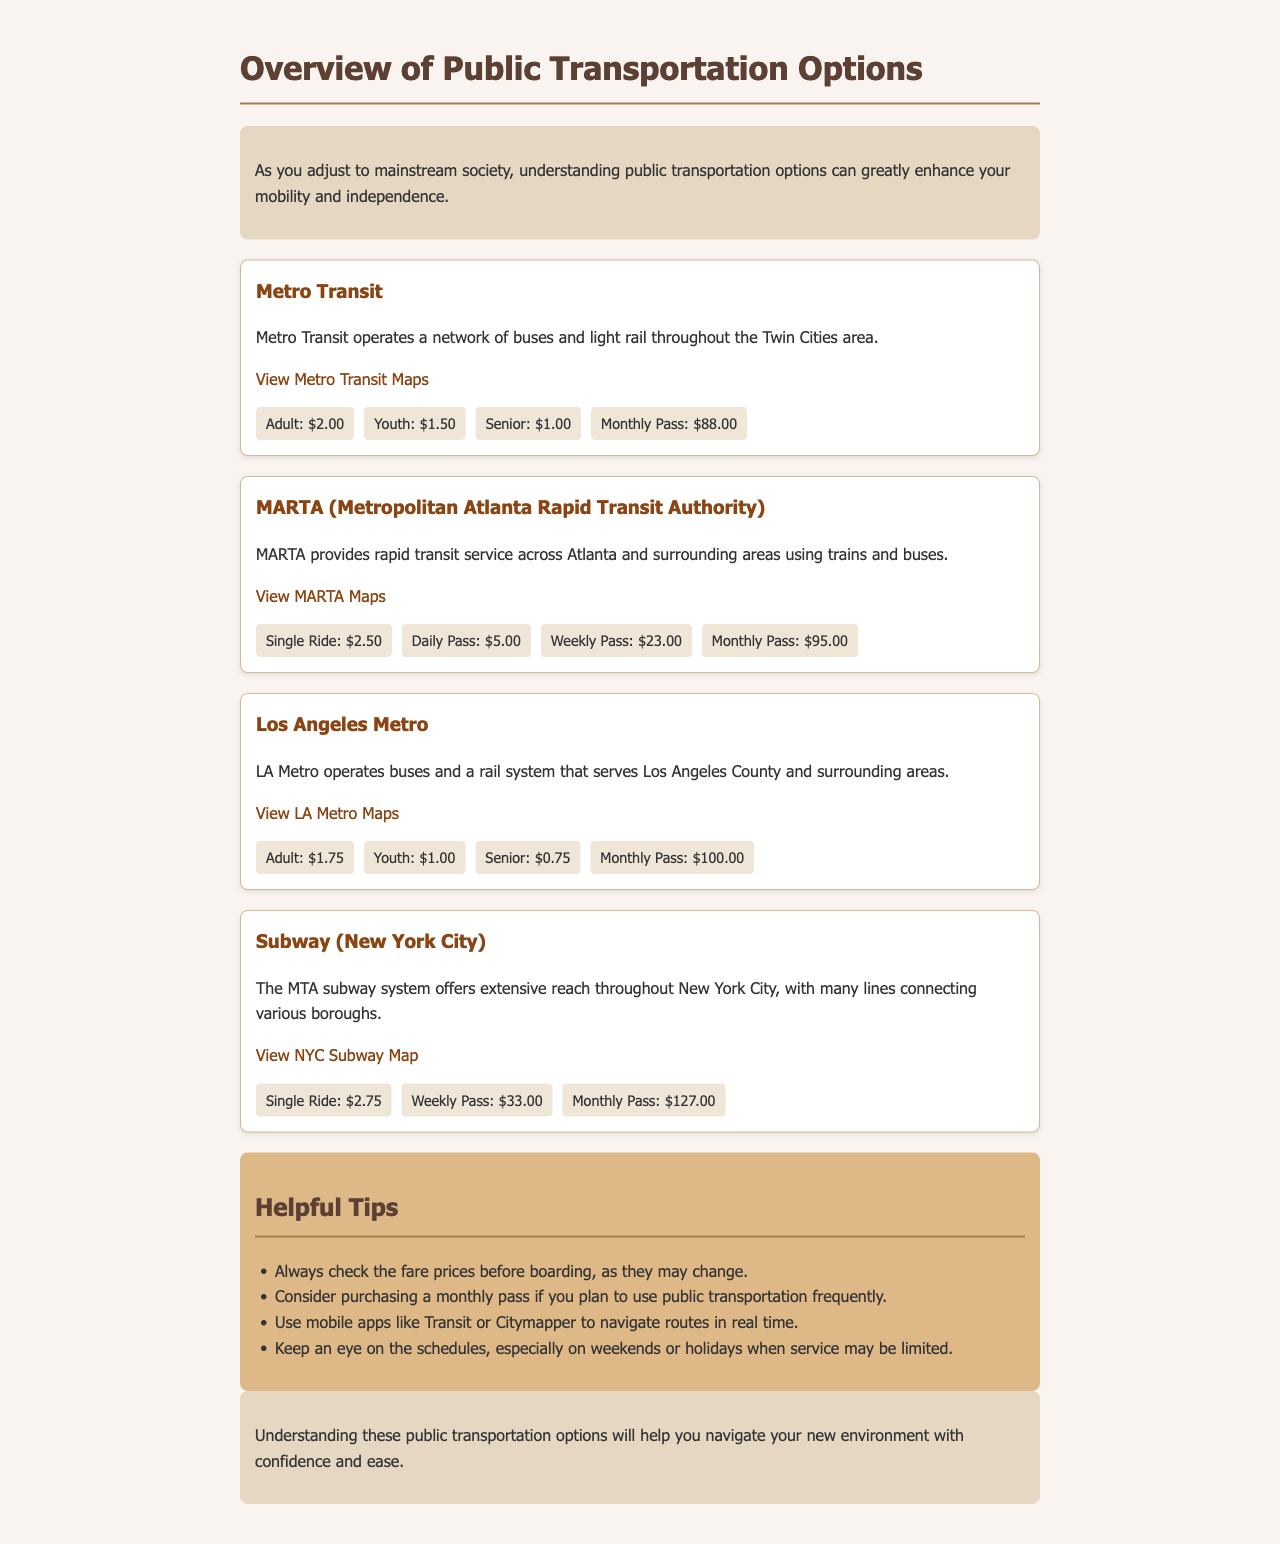What is the fare for an adult using Metro Transit? The fare for an adult using Metro Transit is stated in the fare information section, which specifies the adult fare as $2.00.
Answer: $2.00 What is the monthly pass price for MARTA? The monthly pass price for MARTA is provided in the fare information section, which lists it as $95.00.
Answer: $95.00 How much does a single ride cost on the NYC Subway? The document mentions the fare for a single ride on the NYC Subway, which is $2.75.
Answer: $2.75 Which public transportation option has the lowest senior fare? The lowest senior fare can be determined by comparing the fares listed in the document; the LA Metro has the lowest senior fare of $0.75.
Answer: $0.75 What is a helpful tip mentioned for public transportation? One of the tips provided includes checking the fare prices before boarding, ensuring passengers are informed of any changes.
Answer: Check fare prices before boarding What type of transportation does MARTA provide? The document states that MARTA provides rapid transit service using trains and buses, indicating its mode of transport.
Answer: Trains and buses Which city's public transportation option is the last listed in the document? The transportation option listed last in the document is the Subway system for New York City, which is clearly indicated as the final entry.
Answer: New York City What is the fare for a monthly pass on Los Angeles Metro? The fare for a monthly pass on LA Metro is stated in the fare table as $100.00.
Answer: $100.00 